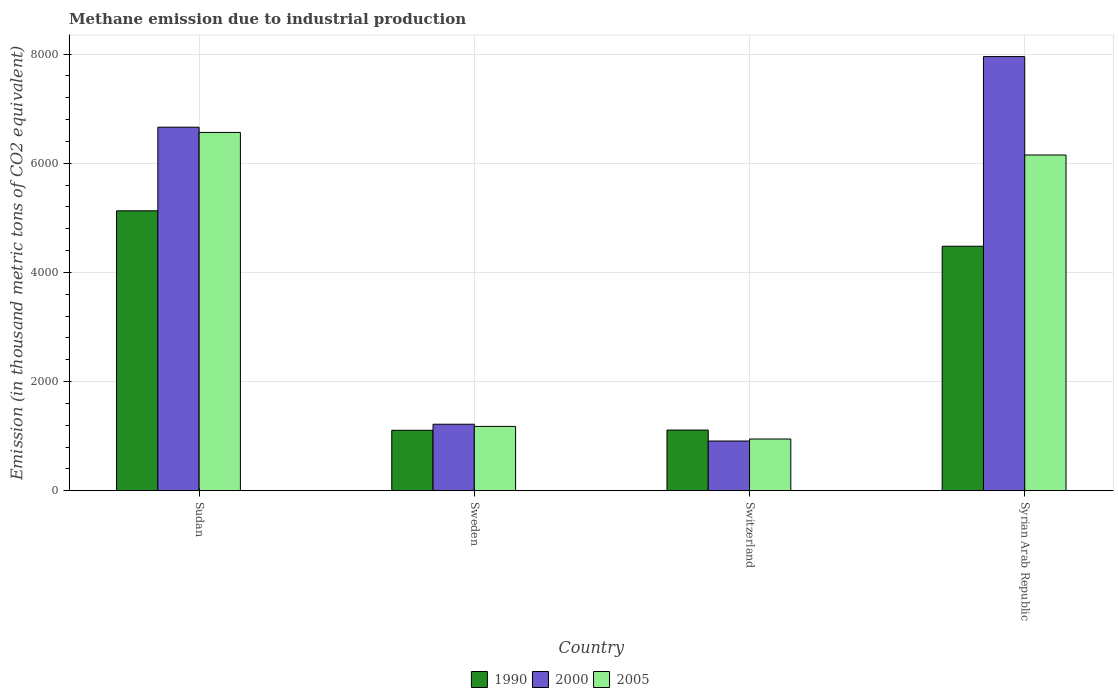How many different coloured bars are there?
Your answer should be compact. 3. Are the number of bars on each tick of the X-axis equal?
Provide a short and direct response. Yes. How many bars are there on the 4th tick from the left?
Ensure brevity in your answer.  3. What is the label of the 2nd group of bars from the left?
Offer a very short reply. Sweden. What is the amount of methane emitted in 2005 in Switzerland?
Offer a very short reply. 948.6. Across all countries, what is the maximum amount of methane emitted in 2000?
Your response must be concise. 7954.6. Across all countries, what is the minimum amount of methane emitted in 1990?
Provide a short and direct response. 1108.1. In which country was the amount of methane emitted in 1990 maximum?
Offer a terse response. Sudan. In which country was the amount of methane emitted in 2000 minimum?
Your answer should be compact. Switzerland. What is the total amount of methane emitted in 1990 in the graph?
Make the answer very short. 1.18e+04. What is the difference between the amount of methane emitted in 1990 in Sudan and that in Switzerland?
Keep it short and to the point. 4016.4. What is the difference between the amount of methane emitted in 2000 in Sweden and the amount of methane emitted in 1990 in Sudan?
Your response must be concise. -3909.8. What is the average amount of methane emitted in 2005 per country?
Ensure brevity in your answer.  3711.2. What is the difference between the amount of methane emitted of/in 1990 and amount of methane emitted of/in 2005 in Switzerland?
Offer a terse response. 164.1. What is the ratio of the amount of methane emitted in 2005 in Switzerland to that in Syrian Arab Republic?
Provide a short and direct response. 0.15. Is the amount of methane emitted in 2000 in Sudan less than that in Sweden?
Offer a very short reply. No. Is the difference between the amount of methane emitted in 1990 in Sweden and Switzerland greater than the difference between the amount of methane emitted in 2005 in Sweden and Switzerland?
Make the answer very short. No. What is the difference between the highest and the second highest amount of methane emitted in 2000?
Offer a terse response. 6735.3. What is the difference between the highest and the lowest amount of methane emitted in 2000?
Make the answer very short. 7043. In how many countries, is the amount of methane emitted in 2005 greater than the average amount of methane emitted in 2005 taken over all countries?
Provide a succinct answer. 2. Is it the case that in every country, the sum of the amount of methane emitted in 1990 and amount of methane emitted in 2005 is greater than the amount of methane emitted in 2000?
Provide a succinct answer. Yes. How many bars are there?
Your response must be concise. 12. How many countries are there in the graph?
Your answer should be compact. 4. What is the difference between two consecutive major ticks on the Y-axis?
Offer a very short reply. 2000. Are the values on the major ticks of Y-axis written in scientific E-notation?
Make the answer very short. No. Does the graph contain any zero values?
Make the answer very short. No. Where does the legend appear in the graph?
Offer a very short reply. Bottom center. How are the legend labels stacked?
Provide a short and direct response. Horizontal. What is the title of the graph?
Your answer should be compact. Methane emission due to industrial production. Does "2000" appear as one of the legend labels in the graph?
Provide a succinct answer. Yes. What is the label or title of the Y-axis?
Offer a terse response. Emission (in thousand metric tons of CO2 equivalent). What is the Emission (in thousand metric tons of CO2 equivalent) of 1990 in Sudan?
Give a very brief answer. 5129.1. What is the Emission (in thousand metric tons of CO2 equivalent) of 2000 in Sudan?
Provide a succinct answer. 6660.9. What is the Emission (in thousand metric tons of CO2 equivalent) of 2005 in Sudan?
Ensure brevity in your answer.  6565.1. What is the Emission (in thousand metric tons of CO2 equivalent) of 1990 in Sweden?
Your answer should be very brief. 1108.1. What is the Emission (in thousand metric tons of CO2 equivalent) of 2000 in Sweden?
Make the answer very short. 1219.3. What is the Emission (in thousand metric tons of CO2 equivalent) of 2005 in Sweden?
Give a very brief answer. 1179.4. What is the Emission (in thousand metric tons of CO2 equivalent) in 1990 in Switzerland?
Provide a succinct answer. 1112.7. What is the Emission (in thousand metric tons of CO2 equivalent) of 2000 in Switzerland?
Your answer should be compact. 911.6. What is the Emission (in thousand metric tons of CO2 equivalent) of 2005 in Switzerland?
Your answer should be very brief. 948.6. What is the Emission (in thousand metric tons of CO2 equivalent) of 1990 in Syrian Arab Republic?
Keep it short and to the point. 4480.2. What is the Emission (in thousand metric tons of CO2 equivalent) of 2000 in Syrian Arab Republic?
Ensure brevity in your answer.  7954.6. What is the Emission (in thousand metric tons of CO2 equivalent) of 2005 in Syrian Arab Republic?
Give a very brief answer. 6151.7. Across all countries, what is the maximum Emission (in thousand metric tons of CO2 equivalent) in 1990?
Your response must be concise. 5129.1. Across all countries, what is the maximum Emission (in thousand metric tons of CO2 equivalent) of 2000?
Your answer should be very brief. 7954.6. Across all countries, what is the maximum Emission (in thousand metric tons of CO2 equivalent) of 2005?
Give a very brief answer. 6565.1. Across all countries, what is the minimum Emission (in thousand metric tons of CO2 equivalent) in 1990?
Keep it short and to the point. 1108.1. Across all countries, what is the minimum Emission (in thousand metric tons of CO2 equivalent) of 2000?
Offer a very short reply. 911.6. Across all countries, what is the minimum Emission (in thousand metric tons of CO2 equivalent) of 2005?
Your answer should be very brief. 948.6. What is the total Emission (in thousand metric tons of CO2 equivalent) of 1990 in the graph?
Your answer should be compact. 1.18e+04. What is the total Emission (in thousand metric tons of CO2 equivalent) in 2000 in the graph?
Your answer should be very brief. 1.67e+04. What is the total Emission (in thousand metric tons of CO2 equivalent) of 2005 in the graph?
Keep it short and to the point. 1.48e+04. What is the difference between the Emission (in thousand metric tons of CO2 equivalent) in 1990 in Sudan and that in Sweden?
Offer a terse response. 4021. What is the difference between the Emission (in thousand metric tons of CO2 equivalent) of 2000 in Sudan and that in Sweden?
Give a very brief answer. 5441.6. What is the difference between the Emission (in thousand metric tons of CO2 equivalent) in 2005 in Sudan and that in Sweden?
Provide a short and direct response. 5385.7. What is the difference between the Emission (in thousand metric tons of CO2 equivalent) in 1990 in Sudan and that in Switzerland?
Give a very brief answer. 4016.4. What is the difference between the Emission (in thousand metric tons of CO2 equivalent) of 2000 in Sudan and that in Switzerland?
Your answer should be very brief. 5749.3. What is the difference between the Emission (in thousand metric tons of CO2 equivalent) of 2005 in Sudan and that in Switzerland?
Keep it short and to the point. 5616.5. What is the difference between the Emission (in thousand metric tons of CO2 equivalent) in 1990 in Sudan and that in Syrian Arab Republic?
Keep it short and to the point. 648.9. What is the difference between the Emission (in thousand metric tons of CO2 equivalent) of 2000 in Sudan and that in Syrian Arab Republic?
Offer a very short reply. -1293.7. What is the difference between the Emission (in thousand metric tons of CO2 equivalent) of 2005 in Sudan and that in Syrian Arab Republic?
Give a very brief answer. 413.4. What is the difference between the Emission (in thousand metric tons of CO2 equivalent) in 1990 in Sweden and that in Switzerland?
Offer a terse response. -4.6. What is the difference between the Emission (in thousand metric tons of CO2 equivalent) in 2000 in Sweden and that in Switzerland?
Your answer should be very brief. 307.7. What is the difference between the Emission (in thousand metric tons of CO2 equivalent) of 2005 in Sweden and that in Switzerland?
Your response must be concise. 230.8. What is the difference between the Emission (in thousand metric tons of CO2 equivalent) in 1990 in Sweden and that in Syrian Arab Republic?
Make the answer very short. -3372.1. What is the difference between the Emission (in thousand metric tons of CO2 equivalent) in 2000 in Sweden and that in Syrian Arab Republic?
Provide a succinct answer. -6735.3. What is the difference between the Emission (in thousand metric tons of CO2 equivalent) in 2005 in Sweden and that in Syrian Arab Republic?
Offer a very short reply. -4972.3. What is the difference between the Emission (in thousand metric tons of CO2 equivalent) in 1990 in Switzerland and that in Syrian Arab Republic?
Your answer should be very brief. -3367.5. What is the difference between the Emission (in thousand metric tons of CO2 equivalent) in 2000 in Switzerland and that in Syrian Arab Republic?
Your answer should be compact. -7043. What is the difference between the Emission (in thousand metric tons of CO2 equivalent) of 2005 in Switzerland and that in Syrian Arab Republic?
Provide a succinct answer. -5203.1. What is the difference between the Emission (in thousand metric tons of CO2 equivalent) of 1990 in Sudan and the Emission (in thousand metric tons of CO2 equivalent) of 2000 in Sweden?
Provide a succinct answer. 3909.8. What is the difference between the Emission (in thousand metric tons of CO2 equivalent) in 1990 in Sudan and the Emission (in thousand metric tons of CO2 equivalent) in 2005 in Sweden?
Your answer should be compact. 3949.7. What is the difference between the Emission (in thousand metric tons of CO2 equivalent) of 2000 in Sudan and the Emission (in thousand metric tons of CO2 equivalent) of 2005 in Sweden?
Offer a terse response. 5481.5. What is the difference between the Emission (in thousand metric tons of CO2 equivalent) in 1990 in Sudan and the Emission (in thousand metric tons of CO2 equivalent) in 2000 in Switzerland?
Your answer should be very brief. 4217.5. What is the difference between the Emission (in thousand metric tons of CO2 equivalent) in 1990 in Sudan and the Emission (in thousand metric tons of CO2 equivalent) in 2005 in Switzerland?
Provide a short and direct response. 4180.5. What is the difference between the Emission (in thousand metric tons of CO2 equivalent) in 2000 in Sudan and the Emission (in thousand metric tons of CO2 equivalent) in 2005 in Switzerland?
Offer a very short reply. 5712.3. What is the difference between the Emission (in thousand metric tons of CO2 equivalent) in 1990 in Sudan and the Emission (in thousand metric tons of CO2 equivalent) in 2000 in Syrian Arab Republic?
Ensure brevity in your answer.  -2825.5. What is the difference between the Emission (in thousand metric tons of CO2 equivalent) in 1990 in Sudan and the Emission (in thousand metric tons of CO2 equivalent) in 2005 in Syrian Arab Republic?
Make the answer very short. -1022.6. What is the difference between the Emission (in thousand metric tons of CO2 equivalent) of 2000 in Sudan and the Emission (in thousand metric tons of CO2 equivalent) of 2005 in Syrian Arab Republic?
Keep it short and to the point. 509.2. What is the difference between the Emission (in thousand metric tons of CO2 equivalent) of 1990 in Sweden and the Emission (in thousand metric tons of CO2 equivalent) of 2000 in Switzerland?
Make the answer very short. 196.5. What is the difference between the Emission (in thousand metric tons of CO2 equivalent) in 1990 in Sweden and the Emission (in thousand metric tons of CO2 equivalent) in 2005 in Switzerland?
Ensure brevity in your answer.  159.5. What is the difference between the Emission (in thousand metric tons of CO2 equivalent) of 2000 in Sweden and the Emission (in thousand metric tons of CO2 equivalent) of 2005 in Switzerland?
Provide a short and direct response. 270.7. What is the difference between the Emission (in thousand metric tons of CO2 equivalent) in 1990 in Sweden and the Emission (in thousand metric tons of CO2 equivalent) in 2000 in Syrian Arab Republic?
Your response must be concise. -6846.5. What is the difference between the Emission (in thousand metric tons of CO2 equivalent) in 1990 in Sweden and the Emission (in thousand metric tons of CO2 equivalent) in 2005 in Syrian Arab Republic?
Your answer should be very brief. -5043.6. What is the difference between the Emission (in thousand metric tons of CO2 equivalent) of 2000 in Sweden and the Emission (in thousand metric tons of CO2 equivalent) of 2005 in Syrian Arab Republic?
Your answer should be very brief. -4932.4. What is the difference between the Emission (in thousand metric tons of CO2 equivalent) of 1990 in Switzerland and the Emission (in thousand metric tons of CO2 equivalent) of 2000 in Syrian Arab Republic?
Make the answer very short. -6841.9. What is the difference between the Emission (in thousand metric tons of CO2 equivalent) in 1990 in Switzerland and the Emission (in thousand metric tons of CO2 equivalent) in 2005 in Syrian Arab Republic?
Provide a succinct answer. -5039. What is the difference between the Emission (in thousand metric tons of CO2 equivalent) in 2000 in Switzerland and the Emission (in thousand metric tons of CO2 equivalent) in 2005 in Syrian Arab Republic?
Ensure brevity in your answer.  -5240.1. What is the average Emission (in thousand metric tons of CO2 equivalent) in 1990 per country?
Offer a very short reply. 2957.53. What is the average Emission (in thousand metric tons of CO2 equivalent) in 2000 per country?
Provide a short and direct response. 4186.6. What is the average Emission (in thousand metric tons of CO2 equivalent) in 2005 per country?
Your response must be concise. 3711.2. What is the difference between the Emission (in thousand metric tons of CO2 equivalent) of 1990 and Emission (in thousand metric tons of CO2 equivalent) of 2000 in Sudan?
Offer a terse response. -1531.8. What is the difference between the Emission (in thousand metric tons of CO2 equivalent) of 1990 and Emission (in thousand metric tons of CO2 equivalent) of 2005 in Sudan?
Ensure brevity in your answer.  -1436. What is the difference between the Emission (in thousand metric tons of CO2 equivalent) of 2000 and Emission (in thousand metric tons of CO2 equivalent) of 2005 in Sudan?
Your answer should be very brief. 95.8. What is the difference between the Emission (in thousand metric tons of CO2 equivalent) of 1990 and Emission (in thousand metric tons of CO2 equivalent) of 2000 in Sweden?
Provide a succinct answer. -111.2. What is the difference between the Emission (in thousand metric tons of CO2 equivalent) of 1990 and Emission (in thousand metric tons of CO2 equivalent) of 2005 in Sweden?
Make the answer very short. -71.3. What is the difference between the Emission (in thousand metric tons of CO2 equivalent) of 2000 and Emission (in thousand metric tons of CO2 equivalent) of 2005 in Sweden?
Give a very brief answer. 39.9. What is the difference between the Emission (in thousand metric tons of CO2 equivalent) of 1990 and Emission (in thousand metric tons of CO2 equivalent) of 2000 in Switzerland?
Offer a very short reply. 201.1. What is the difference between the Emission (in thousand metric tons of CO2 equivalent) in 1990 and Emission (in thousand metric tons of CO2 equivalent) in 2005 in Switzerland?
Provide a succinct answer. 164.1. What is the difference between the Emission (in thousand metric tons of CO2 equivalent) of 2000 and Emission (in thousand metric tons of CO2 equivalent) of 2005 in Switzerland?
Keep it short and to the point. -37. What is the difference between the Emission (in thousand metric tons of CO2 equivalent) in 1990 and Emission (in thousand metric tons of CO2 equivalent) in 2000 in Syrian Arab Republic?
Give a very brief answer. -3474.4. What is the difference between the Emission (in thousand metric tons of CO2 equivalent) in 1990 and Emission (in thousand metric tons of CO2 equivalent) in 2005 in Syrian Arab Republic?
Provide a succinct answer. -1671.5. What is the difference between the Emission (in thousand metric tons of CO2 equivalent) in 2000 and Emission (in thousand metric tons of CO2 equivalent) in 2005 in Syrian Arab Republic?
Provide a short and direct response. 1802.9. What is the ratio of the Emission (in thousand metric tons of CO2 equivalent) in 1990 in Sudan to that in Sweden?
Ensure brevity in your answer.  4.63. What is the ratio of the Emission (in thousand metric tons of CO2 equivalent) in 2000 in Sudan to that in Sweden?
Your answer should be compact. 5.46. What is the ratio of the Emission (in thousand metric tons of CO2 equivalent) in 2005 in Sudan to that in Sweden?
Your answer should be very brief. 5.57. What is the ratio of the Emission (in thousand metric tons of CO2 equivalent) in 1990 in Sudan to that in Switzerland?
Provide a succinct answer. 4.61. What is the ratio of the Emission (in thousand metric tons of CO2 equivalent) of 2000 in Sudan to that in Switzerland?
Your answer should be compact. 7.31. What is the ratio of the Emission (in thousand metric tons of CO2 equivalent) in 2005 in Sudan to that in Switzerland?
Your answer should be very brief. 6.92. What is the ratio of the Emission (in thousand metric tons of CO2 equivalent) of 1990 in Sudan to that in Syrian Arab Republic?
Provide a short and direct response. 1.14. What is the ratio of the Emission (in thousand metric tons of CO2 equivalent) of 2000 in Sudan to that in Syrian Arab Republic?
Provide a short and direct response. 0.84. What is the ratio of the Emission (in thousand metric tons of CO2 equivalent) of 2005 in Sudan to that in Syrian Arab Republic?
Make the answer very short. 1.07. What is the ratio of the Emission (in thousand metric tons of CO2 equivalent) of 1990 in Sweden to that in Switzerland?
Offer a terse response. 1. What is the ratio of the Emission (in thousand metric tons of CO2 equivalent) of 2000 in Sweden to that in Switzerland?
Make the answer very short. 1.34. What is the ratio of the Emission (in thousand metric tons of CO2 equivalent) of 2005 in Sweden to that in Switzerland?
Provide a short and direct response. 1.24. What is the ratio of the Emission (in thousand metric tons of CO2 equivalent) of 1990 in Sweden to that in Syrian Arab Republic?
Make the answer very short. 0.25. What is the ratio of the Emission (in thousand metric tons of CO2 equivalent) of 2000 in Sweden to that in Syrian Arab Republic?
Keep it short and to the point. 0.15. What is the ratio of the Emission (in thousand metric tons of CO2 equivalent) in 2005 in Sweden to that in Syrian Arab Republic?
Make the answer very short. 0.19. What is the ratio of the Emission (in thousand metric tons of CO2 equivalent) of 1990 in Switzerland to that in Syrian Arab Republic?
Provide a short and direct response. 0.25. What is the ratio of the Emission (in thousand metric tons of CO2 equivalent) of 2000 in Switzerland to that in Syrian Arab Republic?
Provide a succinct answer. 0.11. What is the ratio of the Emission (in thousand metric tons of CO2 equivalent) of 2005 in Switzerland to that in Syrian Arab Republic?
Offer a terse response. 0.15. What is the difference between the highest and the second highest Emission (in thousand metric tons of CO2 equivalent) of 1990?
Offer a very short reply. 648.9. What is the difference between the highest and the second highest Emission (in thousand metric tons of CO2 equivalent) of 2000?
Provide a short and direct response. 1293.7. What is the difference between the highest and the second highest Emission (in thousand metric tons of CO2 equivalent) of 2005?
Ensure brevity in your answer.  413.4. What is the difference between the highest and the lowest Emission (in thousand metric tons of CO2 equivalent) in 1990?
Your response must be concise. 4021. What is the difference between the highest and the lowest Emission (in thousand metric tons of CO2 equivalent) of 2000?
Make the answer very short. 7043. What is the difference between the highest and the lowest Emission (in thousand metric tons of CO2 equivalent) in 2005?
Offer a terse response. 5616.5. 